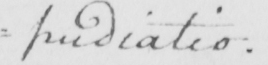Transcribe the text shown in this historical manuscript line. =pudiatio . 